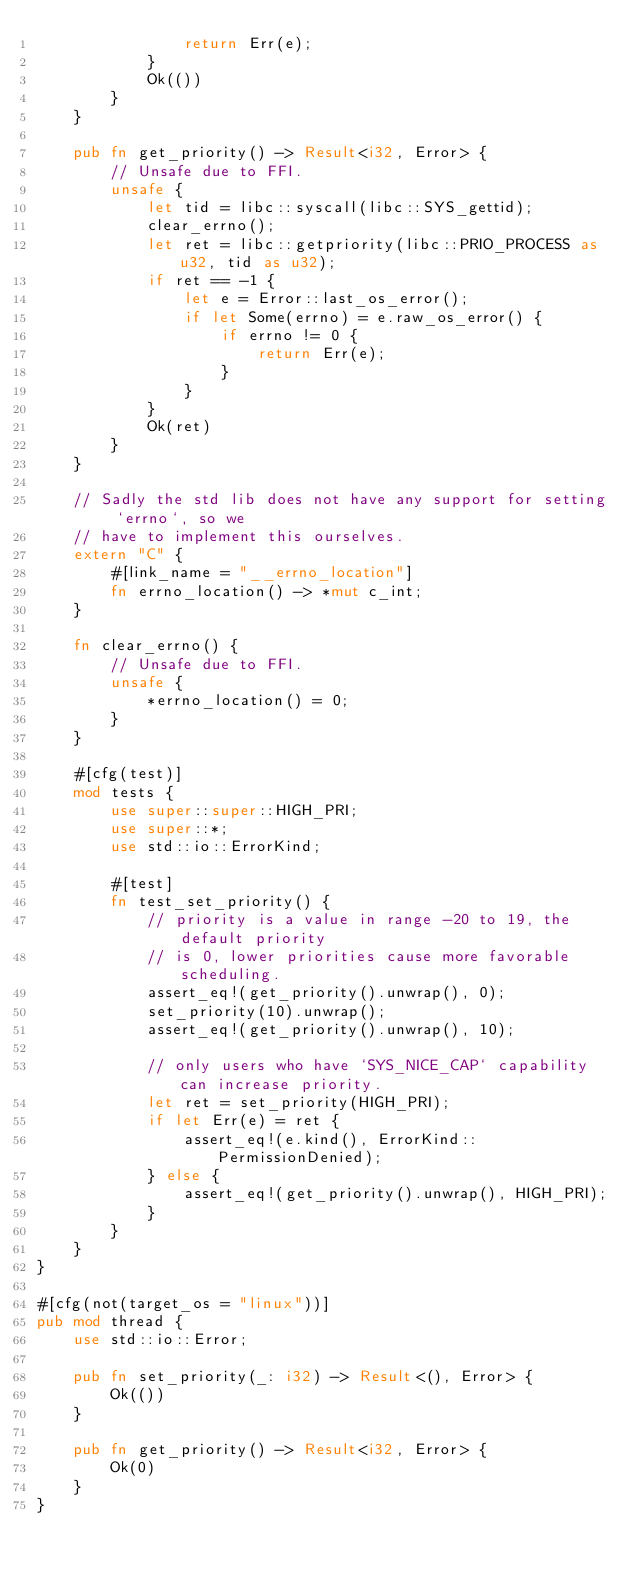Convert code to text. <code><loc_0><loc_0><loc_500><loc_500><_Rust_>                return Err(e);
            }
            Ok(())
        }
    }

    pub fn get_priority() -> Result<i32, Error> {
        // Unsafe due to FFI.
        unsafe {
            let tid = libc::syscall(libc::SYS_gettid);
            clear_errno();
            let ret = libc::getpriority(libc::PRIO_PROCESS as u32, tid as u32);
            if ret == -1 {
                let e = Error::last_os_error();
                if let Some(errno) = e.raw_os_error() {
                    if errno != 0 {
                        return Err(e);
                    }
                }
            }
            Ok(ret)
        }
    }

    // Sadly the std lib does not have any support for setting `errno`, so we
    // have to implement this ourselves.
    extern "C" {
        #[link_name = "__errno_location"]
        fn errno_location() -> *mut c_int;
    }

    fn clear_errno() {
        // Unsafe due to FFI.
        unsafe {
            *errno_location() = 0;
        }
    }

    #[cfg(test)]
    mod tests {
        use super::super::HIGH_PRI;
        use super::*;
        use std::io::ErrorKind;

        #[test]
        fn test_set_priority() {
            // priority is a value in range -20 to 19, the default priority
            // is 0, lower priorities cause more favorable scheduling.
            assert_eq!(get_priority().unwrap(), 0);
            set_priority(10).unwrap();
            assert_eq!(get_priority().unwrap(), 10);

            // only users who have `SYS_NICE_CAP` capability can increase priority.
            let ret = set_priority(HIGH_PRI);
            if let Err(e) = ret {
                assert_eq!(e.kind(), ErrorKind::PermissionDenied);
            } else {
                assert_eq!(get_priority().unwrap(), HIGH_PRI);
            }
        }
    }
}

#[cfg(not(target_os = "linux"))]
pub mod thread {
    use std::io::Error;

    pub fn set_priority(_: i32) -> Result<(), Error> {
        Ok(())
    }

    pub fn get_priority() -> Result<i32, Error> {
        Ok(0)
    }
}
</code> 